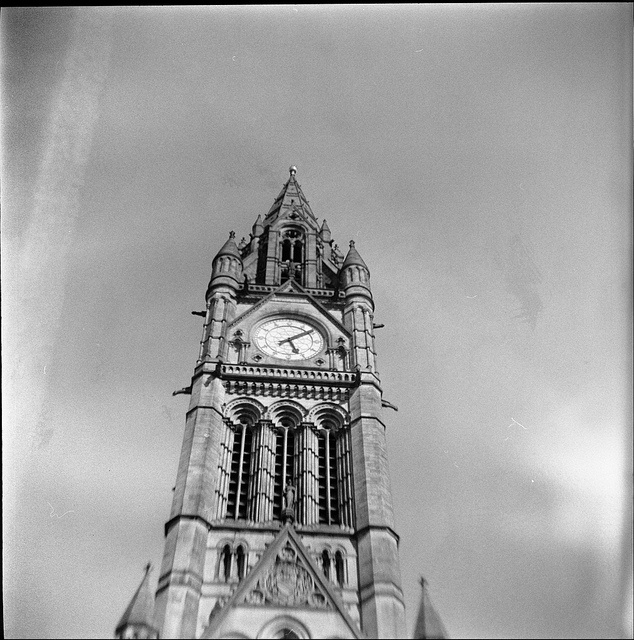Describe the objects in this image and their specific colors. I can see a clock in black, lightgray, darkgray, and gray tones in this image. 